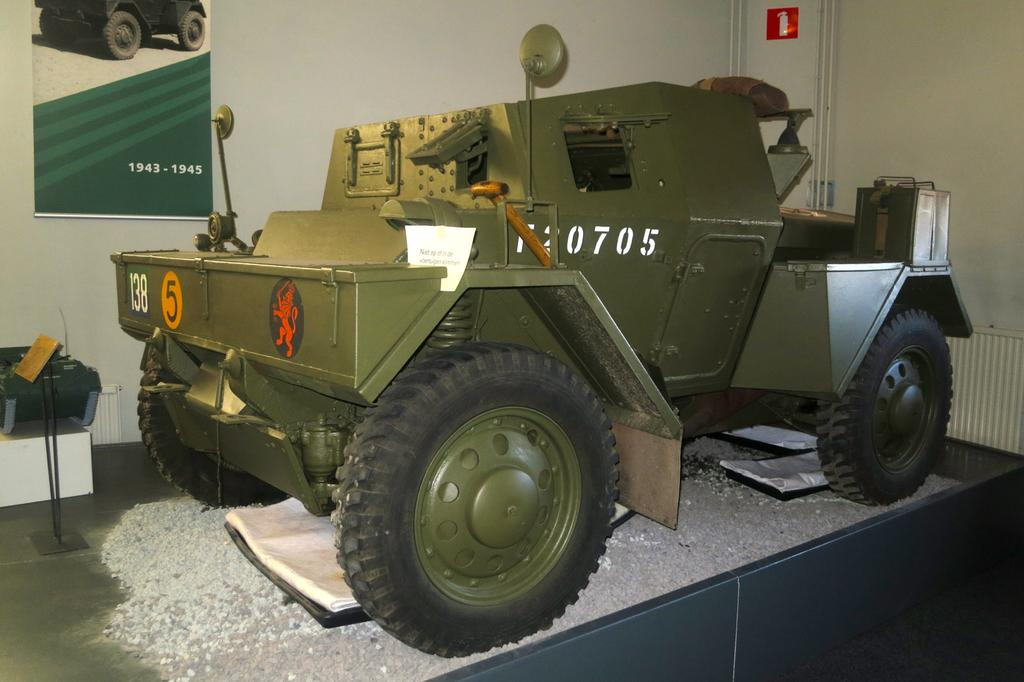What is the main subject in the foreground of the image? There is a truck in the foreground of the image. What is the truck placed on? The truck is placed on a surface. What can be seen in the background of the image? The background of the image is the sky. How many kittens are sitting on the truck's roof in the image? There are no kittens present in the image, so it is not possible to determine how many might be sitting on the truck's roof. 